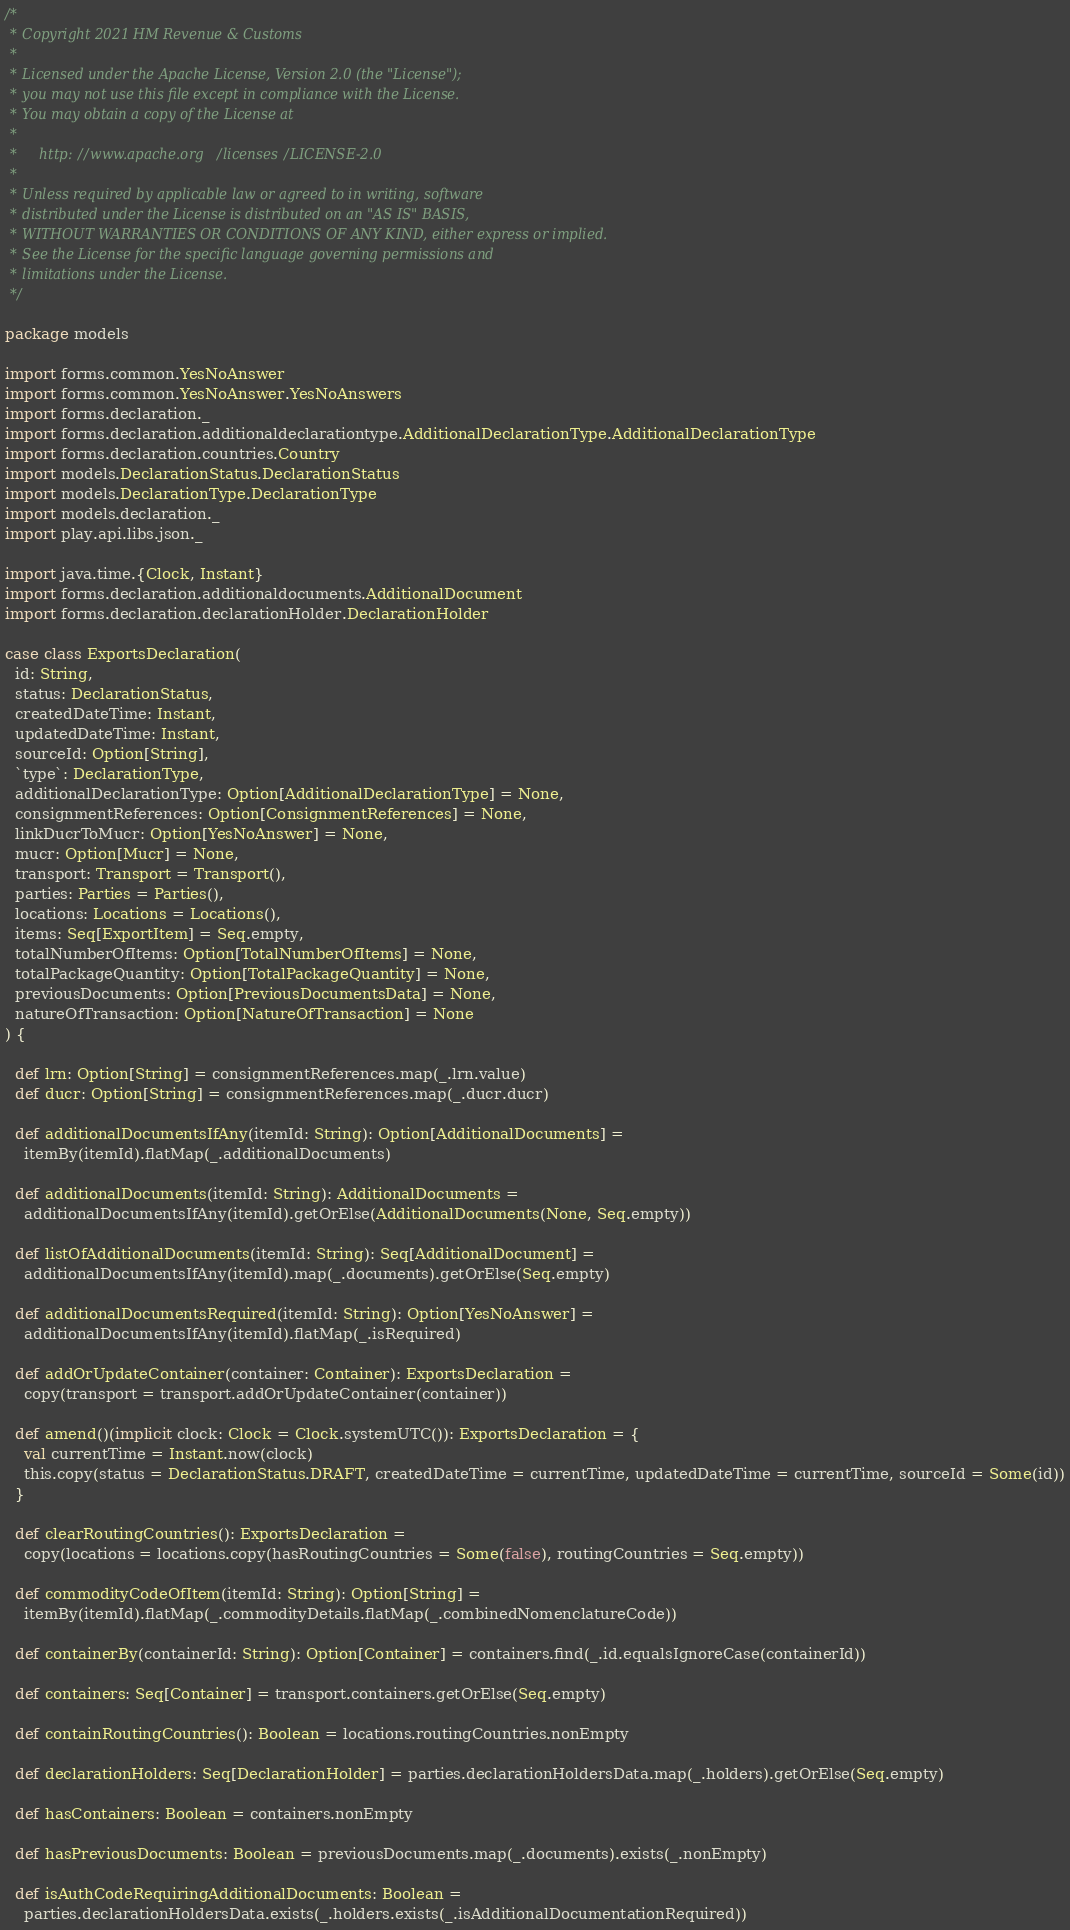Convert code to text. <code><loc_0><loc_0><loc_500><loc_500><_Scala_>/*
 * Copyright 2021 HM Revenue & Customs
 *
 * Licensed under the Apache License, Version 2.0 (the "License");
 * you may not use this file except in compliance with the License.
 * You may obtain a copy of the License at
 *
 *     http://www.apache.org/licenses/LICENSE-2.0
 *
 * Unless required by applicable law or agreed to in writing, software
 * distributed under the License is distributed on an "AS IS" BASIS,
 * WITHOUT WARRANTIES OR CONDITIONS OF ANY KIND, either express or implied.
 * See the License for the specific language governing permissions and
 * limitations under the License.
 */

package models

import forms.common.YesNoAnswer
import forms.common.YesNoAnswer.YesNoAnswers
import forms.declaration._
import forms.declaration.additionaldeclarationtype.AdditionalDeclarationType.AdditionalDeclarationType
import forms.declaration.countries.Country
import models.DeclarationStatus.DeclarationStatus
import models.DeclarationType.DeclarationType
import models.declaration._
import play.api.libs.json._

import java.time.{Clock, Instant}
import forms.declaration.additionaldocuments.AdditionalDocument
import forms.declaration.declarationHolder.DeclarationHolder

case class ExportsDeclaration(
  id: String,
  status: DeclarationStatus,
  createdDateTime: Instant,
  updatedDateTime: Instant,
  sourceId: Option[String],
  `type`: DeclarationType,
  additionalDeclarationType: Option[AdditionalDeclarationType] = None,
  consignmentReferences: Option[ConsignmentReferences] = None,
  linkDucrToMucr: Option[YesNoAnswer] = None,
  mucr: Option[Mucr] = None,
  transport: Transport = Transport(),
  parties: Parties = Parties(),
  locations: Locations = Locations(),
  items: Seq[ExportItem] = Seq.empty,
  totalNumberOfItems: Option[TotalNumberOfItems] = None,
  totalPackageQuantity: Option[TotalPackageQuantity] = None,
  previousDocuments: Option[PreviousDocumentsData] = None,
  natureOfTransaction: Option[NatureOfTransaction] = None
) {

  def lrn: Option[String] = consignmentReferences.map(_.lrn.value)
  def ducr: Option[String] = consignmentReferences.map(_.ducr.ducr)

  def additionalDocumentsIfAny(itemId: String): Option[AdditionalDocuments] =
    itemBy(itemId).flatMap(_.additionalDocuments)

  def additionalDocuments(itemId: String): AdditionalDocuments =
    additionalDocumentsIfAny(itemId).getOrElse(AdditionalDocuments(None, Seq.empty))

  def listOfAdditionalDocuments(itemId: String): Seq[AdditionalDocument] =
    additionalDocumentsIfAny(itemId).map(_.documents).getOrElse(Seq.empty)

  def additionalDocumentsRequired(itemId: String): Option[YesNoAnswer] =
    additionalDocumentsIfAny(itemId).flatMap(_.isRequired)

  def addOrUpdateContainer(container: Container): ExportsDeclaration =
    copy(transport = transport.addOrUpdateContainer(container))

  def amend()(implicit clock: Clock = Clock.systemUTC()): ExportsDeclaration = {
    val currentTime = Instant.now(clock)
    this.copy(status = DeclarationStatus.DRAFT, createdDateTime = currentTime, updatedDateTime = currentTime, sourceId = Some(id))
  }

  def clearRoutingCountries(): ExportsDeclaration =
    copy(locations = locations.copy(hasRoutingCountries = Some(false), routingCountries = Seq.empty))

  def commodityCodeOfItem(itemId: String): Option[String] =
    itemBy(itemId).flatMap(_.commodityDetails.flatMap(_.combinedNomenclatureCode))

  def containerBy(containerId: String): Option[Container] = containers.find(_.id.equalsIgnoreCase(containerId))

  def containers: Seq[Container] = transport.containers.getOrElse(Seq.empty)

  def containRoutingCountries(): Boolean = locations.routingCountries.nonEmpty

  def declarationHolders: Seq[DeclarationHolder] = parties.declarationHoldersData.map(_.holders).getOrElse(Seq.empty)

  def hasContainers: Boolean = containers.nonEmpty

  def hasPreviousDocuments: Boolean = previousDocuments.map(_.documents).exists(_.nonEmpty)

  def isAuthCodeRequiringAdditionalDocuments: Boolean =
    parties.declarationHoldersData.exists(_.holders.exists(_.isAdditionalDocumentationRequired))
</code> 